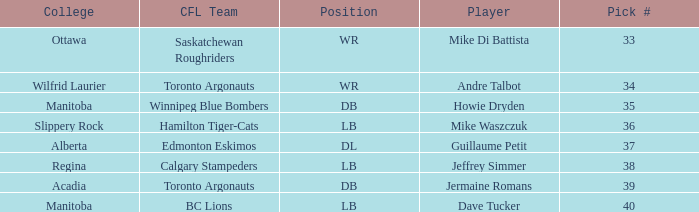What Player has a College that is alberta? Guillaume Petit. 